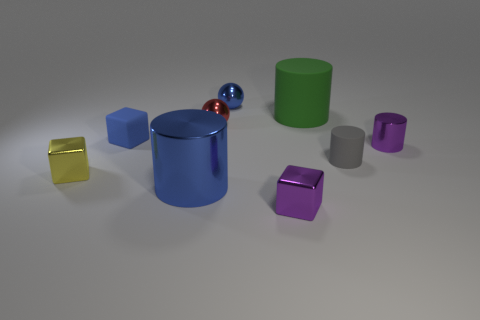What is the size of the gray rubber object that is the same shape as the big green matte object?
Offer a very short reply. Small. Are there any blue matte objects to the left of the tiny ball that is in front of the matte cylinder that is to the left of the tiny gray matte cylinder?
Offer a very short reply. Yes. Is the color of the tiny matte cube the same as the big shiny thing?
Ensure brevity in your answer.  Yes. Is the number of large green matte cylinders less than the number of small green cylinders?
Provide a succinct answer. No. Is the material of the red object to the left of the green thing the same as the small blue thing in front of the green object?
Your response must be concise. No. Are there fewer red things in front of the yellow block than small blue balls?
Give a very brief answer. Yes. How many small metal balls are in front of the small metal sphere that is in front of the small blue sphere?
Provide a short and direct response. 0. What size is the shiny object that is both in front of the tiny blue rubber cube and behind the yellow cube?
Provide a short and direct response. Small. Do the tiny yellow object and the small blue thing that is left of the small blue metal ball have the same material?
Keep it short and to the point. No. Is the number of small yellow objects that are on the right side of the small yellow block less than the number of purple cubes that are in front of the gray rubber cylinder?
Provide a short and direct response. Yes. 